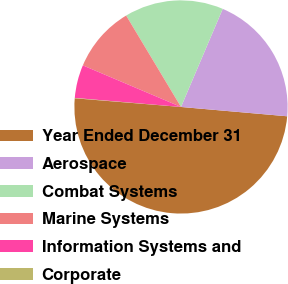Convert chart. <chart><loc_0><loc_0><loc_500><loc_500><pie_chart><fcel>Year Ended December 31<fcel>Aerospace<fcel>Combat Systems<fcel>Marine Systems<fcel>Information Systems and<fcel>Corporate<nl><fcel>49.9%<fcel>19.99%<fcel>15.0%<fcel>10.02%<fcel>5.03%<fcel>0.05%<nl></chart> 